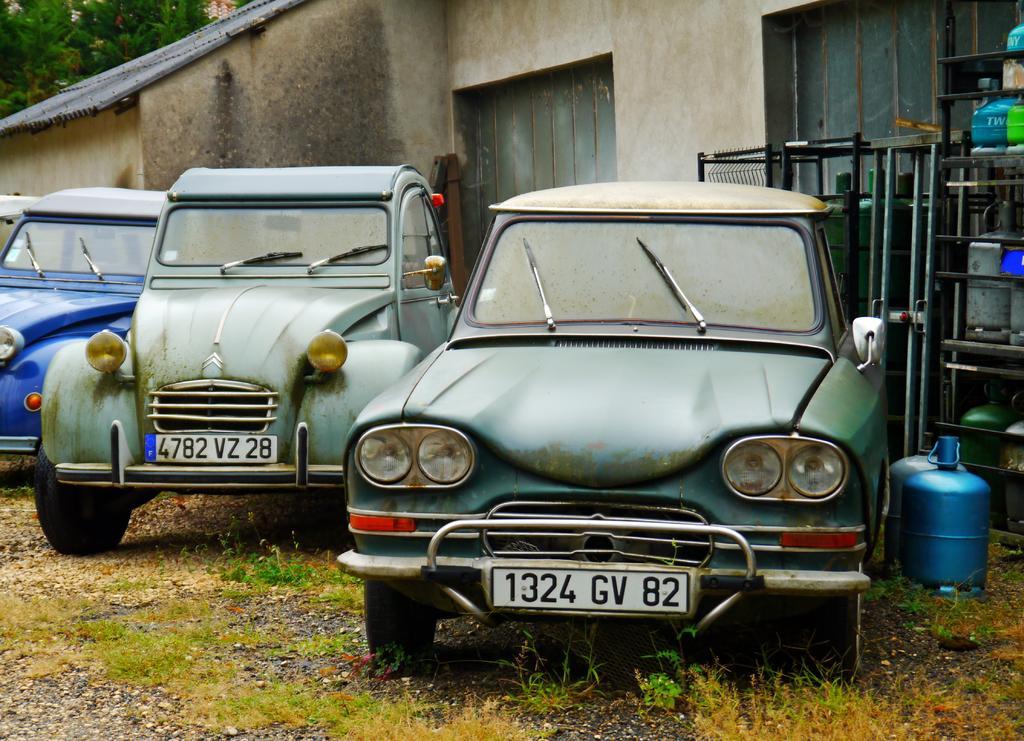Can you describe this image briefly? There are three cars, which are parked. I can see the headlights, number plates, bumpers, glass wipers, side mirrors are attached to the cars. These look like cans, which are placed on the ground. These look like the racks with few objects in it. This is a building with windows. I think this is a tree. Here is the grass. 